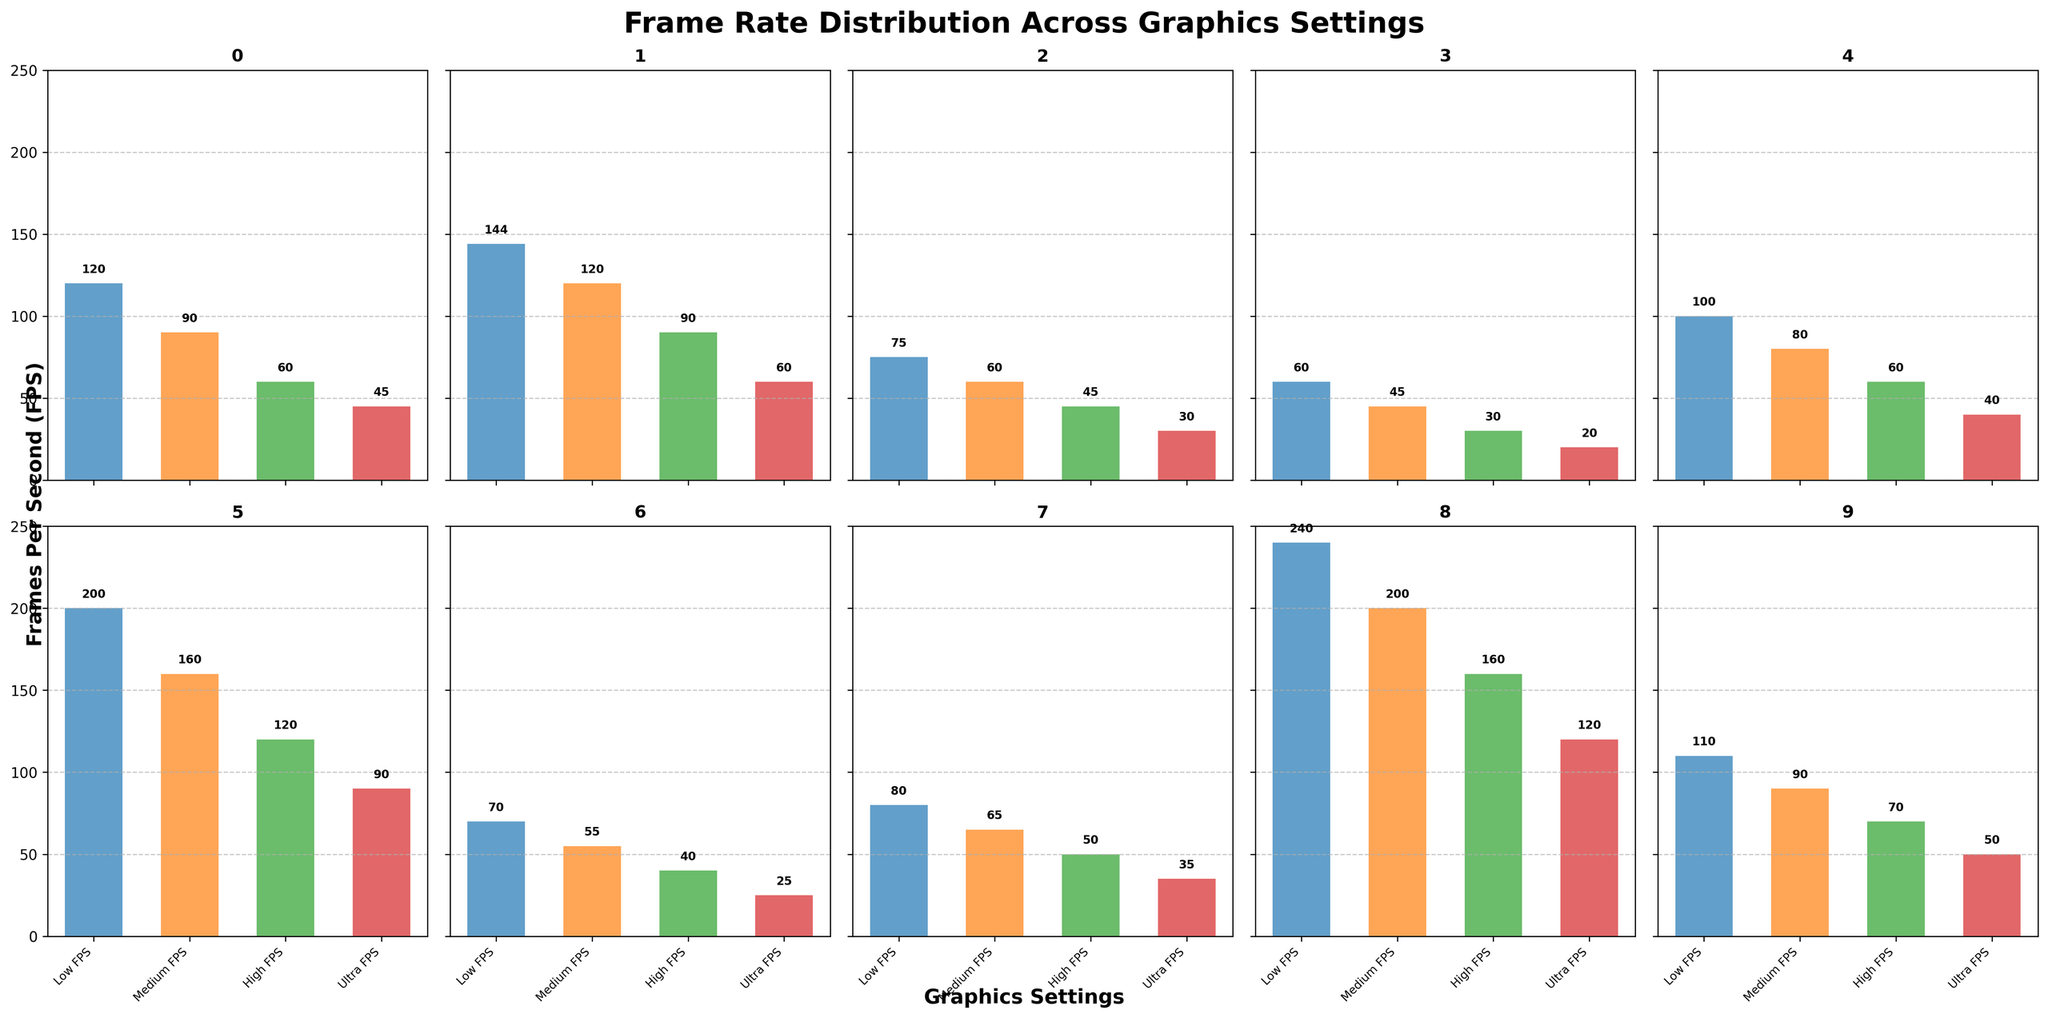What is the highest FPS value recorded for Cyberpunk 2077? The highest FPS value can be identified by locating the bar with the tallest height in the subplot for Cyberpunk 2077. The Low FPS bar shows the highest value.
Answer: 60 Which game has the lowest FPS for Ultra settings? The subplot displaying the Ultra FPS values for each game must be individually checked. Cyberpunk 2077 has the lowest Ultra FPS value.
Answer: Cyberpunk 2077 What is the difference in FPS between Low and Ultra settings for Fortnite? In the Fortnite subplot, identify the FPS values for Low and Ultra settings. Subtract the Ultra FPS value from the Low FPS value (144 - 60).
Answer: 84 For which graphics setting does Valorant have the highest FPS? By examining the Valorant subplot, the tallest bar corresponds to the Low FPS setting.
Answer: Low FPS Which game shows the smallest reduction in FPS from Low to Medium settings? Compare the difference between Low and Medium FPS values for each game. Minecraft shows the smallest reduction (120 - 90 = 30).
Answer: Minecraft Calculate the average Ultra FPS for all games. Sum the Ultra FPS values across all games (45 + 60 + 30 + 20 + 40 + 90 + 25 + 35 + 120 + 50) and divide by the number of games (10).
Answer: 51.5 Which game has the most consistent FPS across all graphics settings? Identify the game with the smallest range of FPS values by looking at the consistency of bar heights. Assassin's Creed Valhalla (80, 65, 50, 35) has the most consistent FPS (difference of 45).
Answer: Assassin's Creed Valhalla How does the High FPS for Red Dead Redemption 2 compare to the Medium FPS for The Witcher 3? Find the High FPS value for Red Dead Redemption 2 and the Medium FPS value for The Witcher 3. Red Dead Redemption 2 has 40 FPS and The Witcher 3 has 60 FPS; thus, High FPS for Red Dead Redemption 2 is less than Medium FPS for The Witcher 3.
Answer: Less What is the increase in FPS from Medium to High settings for Grand Theft Auto V? Locate the Medium and High FPS values for Grand Theft Auto V. Subtract the Medium FPS from the High FPS (60 - 80).
Answer: 20 